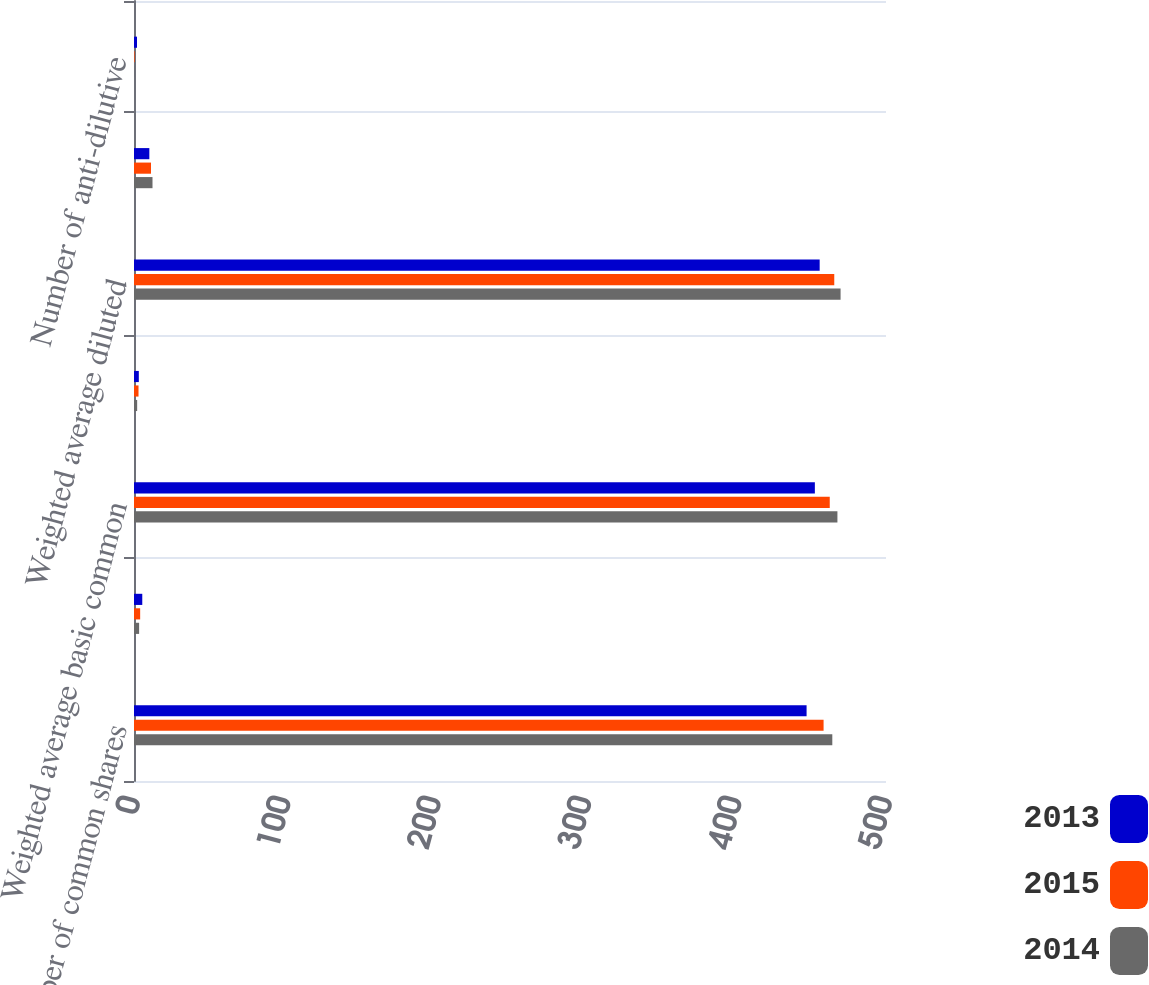Convert chart to OTSL. <chart><loc_0><loc_0><loc_500><loc_500><stacked_bar_chart><ecel><fcel>Number of common shares<fcel>Effect of using weighted<fcel>Weighted average basic common<fcel>Dilutive effect of<fcel>Weighted average diluted<fcel>Potentially issuable shares<fcel>Number of anti-dilutive<nl><fcel>2013<fcel>447.2<fcel>5.5<fcel>452.7<fcel>3.2<fcel>455.9<fcel>10.2<fcel>2<nl><fcel>2015<fcel>458.5<fcel>4.1<fcel>462.6<fcel>3<fcel>465.6<fcel>11.3<fcel>0.4<nl><fcel>2014<fcel>464.3<fcel>3.4<fcel>467.7<fcel>2.1<fcel>469.8<fcel>12.3<fcel>0.1<nl></chart> 